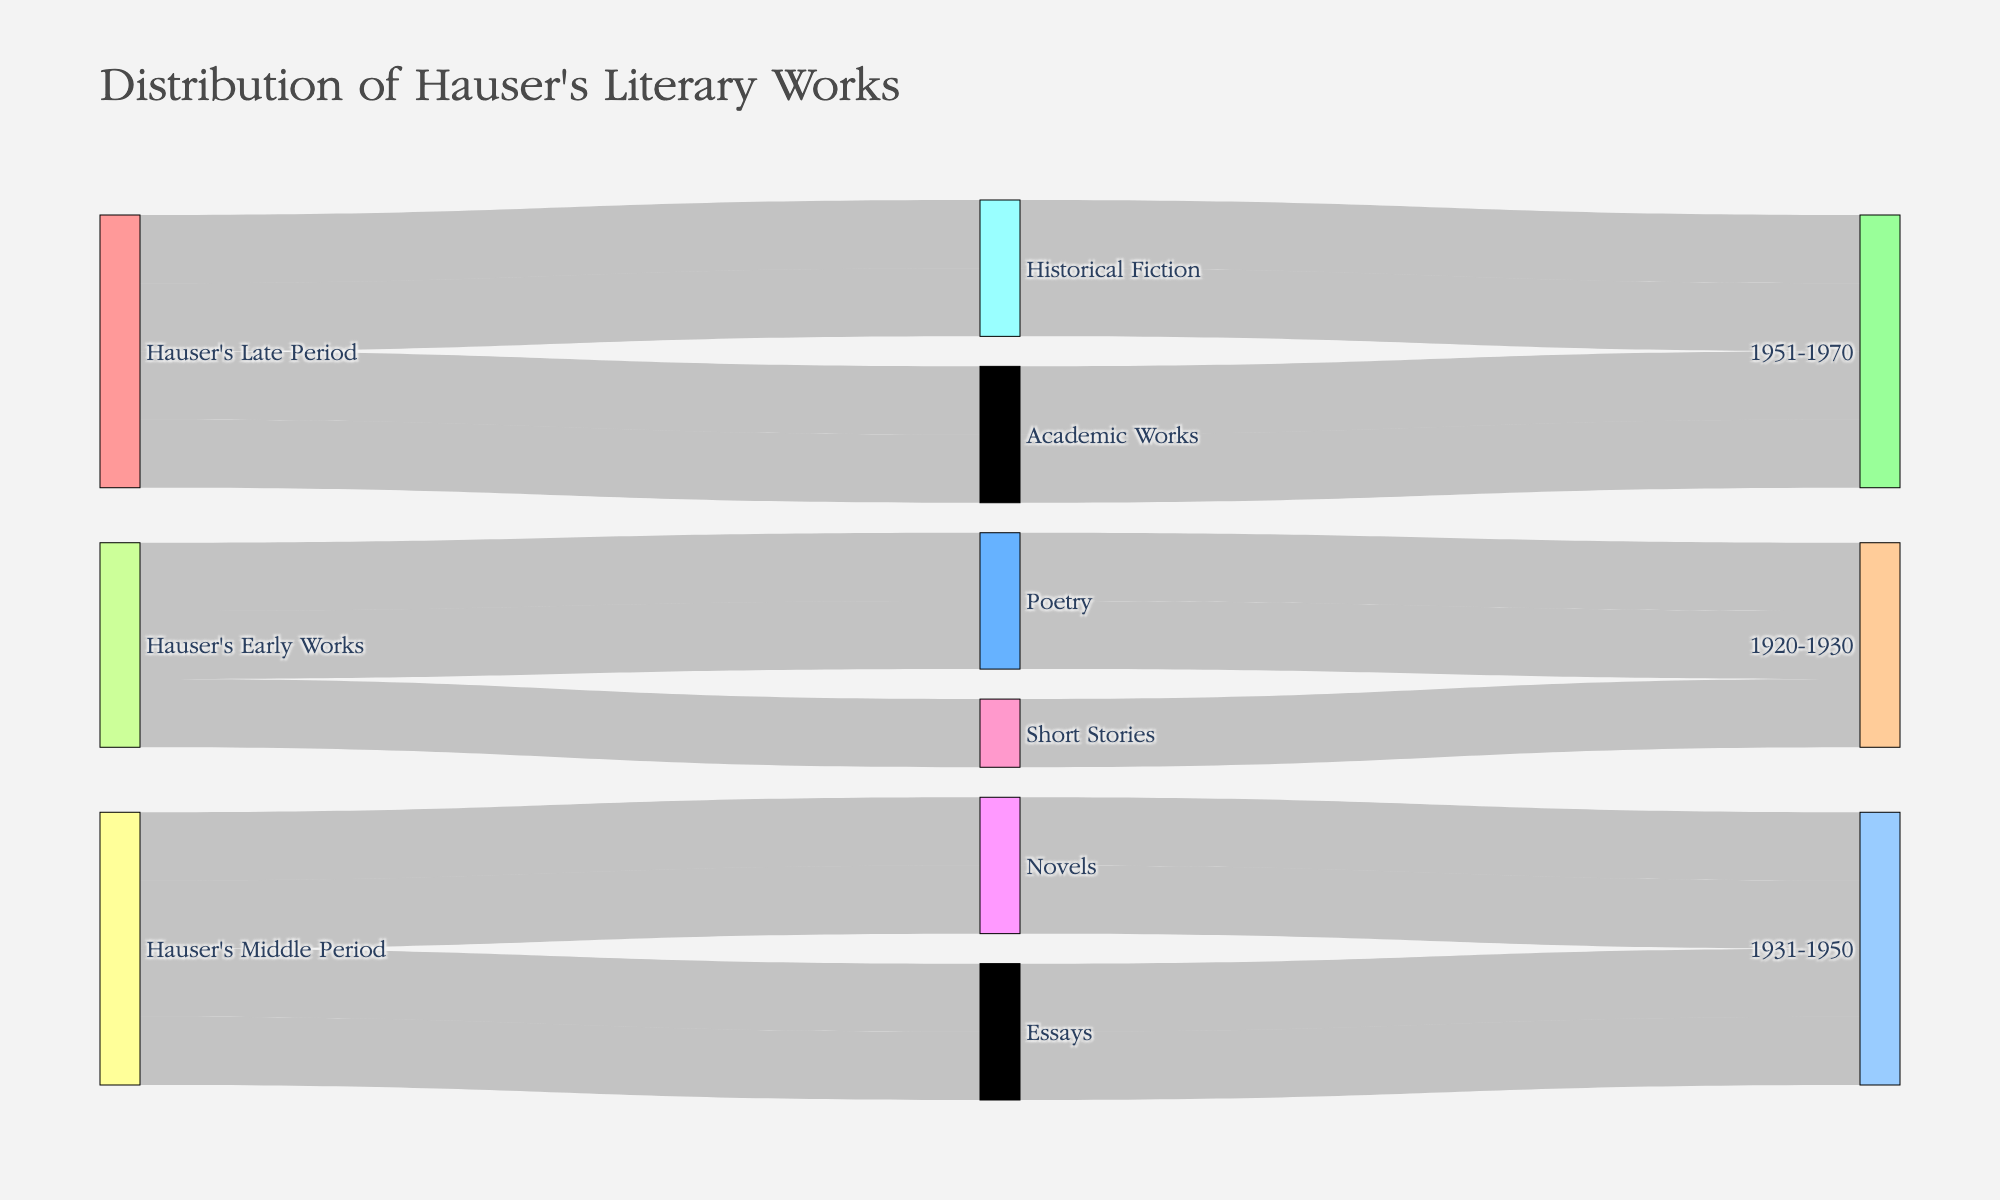What is the title of the Sankey Diagram? The title is displayed at the top of the diagram, and it describes the overall content of the figure, which is "Distribution of Hauser's Literary Works."
Answer: Distribution of Hauser's Literary Works Which genre did Hauser primarily focus on during the early period (1920-1930)? By following the connections from "Hauser's Early Works" to the "1920-1930" period, we see that poetry and short stories are the genres. Since Poetry has two works (Sonnets of Youth and Odes to Nature), it indicates a primary focus.
Answer: Poetry How many works did Hauser produce in the middle period (1931-1950)? Follow the connections from the "1931-1950" time period to the genres. There are connections to Novels and Essays, with two works each in these genres. The total is 2+2=4.
Answer: 4 Which genre had an equal number of works across different time periods? Look at the connections from all time periods to the genres and count the number of works. Historical Fiction (2 works in Late Period) and Essays (2 works in Middle Period) show equal distribution across different time periods.
Answer: Essays Is "Roman Echoes" classified as a novel or short story? Locate "Roman Echoes" in the diagram and trace its path back through the genre. "Roman Echoes" is classified under the "Novels" genre.
Answer: Novels Compare the number of works in the "Academic Works" genre and the "Historical Fiction" genre. Which has more? Count the number of works linked to "Academic Works" and "Historical Fiction." Both "Historical Fiction" and "Academic Works" have 2 works each, resulting in a tie.
Answer: Tie Which period had the most diverse genres in Hauser's works? Count the distinct genres connected to each time period. The early period has Poetry (2) and Short Stories (1), the middle period has Novels (2) and Essays (2), and the late period has Historical Fiction (2) and Academic Works (2). Both the Middle and Late periods display an equal diversity of 2 genres each.
Answer: Middle and Late Periods Did Hauser write more works of poetry or essays during his career? Count the number of works linked to Poetry and Essays in the diagram. Poetry has 2 works, and Essays also have 2 works. It shows an equal amount.
Answer: Equal Which single work connects to the genre of "Short Stories"? By examining the connections specifically within the "Short Stories" genre, "Tales from Antiquity" is the sole work connected.
Answer: Tales from Antiquity How many genres did Hauser work in during the late period (1951-1970)? Trace the connections from the "1951-1970" period to the genres. He worked in two genres: Historical Fiction and Academic Works.
Answer: 2 